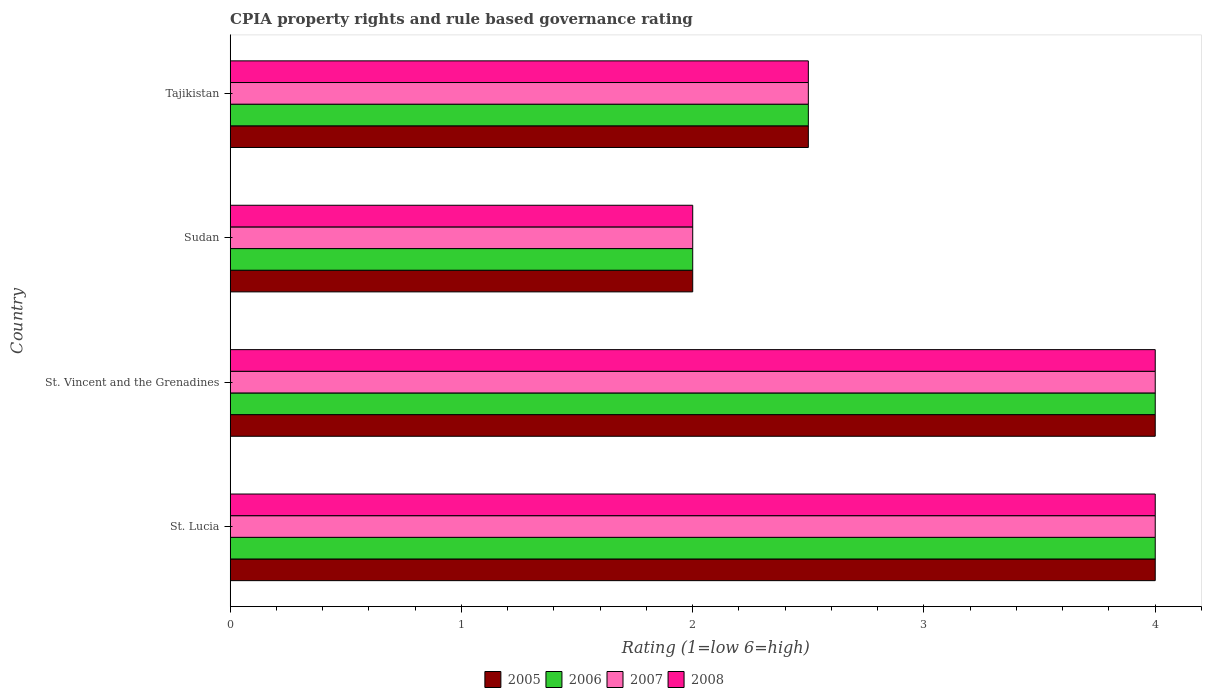How many different coloured bars are there?
Offer a terse response. 4. Are the number of bars on each tick of the Y-axis equal?
Keep it short and to the point. Yes. How many bars are there on the 3rd tick from the top?
Provide a short and direct response. 4. What is the label of the 2nd group of bars from the top?
Offer a terse response. Sudan. What is the CPIA rating in 2005 in Sudan?
Keep it short and to the point. 2. Across all countries, what is the maximum CPIA rating in 2005?
Offer a terse response. 4. In which country was the CPIA rating in 2005 maximum?
Provide a succinct answer. St. Lucia. In which country was the CPIA rating in 2007 minimum?
Give a very brief answer. Sudan. What is the difference between the CPIA rating in 2005 in St. Vincent and the Grenadines and the CPIA rating in 2007 in Tajikistan?
Ensure brevity in your answer.  1.5. What is the average CPIA rating in 2008 per country?
Provide a short and direct response. 3.12. What is the difference between the CPIA rating in 2006 and CPIA rating in 2005 in St. Lucia?
Keep it short and to the point. 0. In how many countries, is the CPIA rating in 2006 greater than 1.8 ?
Keep it short and to the point. 4. What is the ratio of the CPIA rating in 2005 in St. Lucia to that in St. Vincent and the Grenadines?
Ensure brevity in your answer.  1. What is the difference between the highest and the second highest CPIA rating in 2007?
Offer a terse response. 0. In how many countries, is the CPIA rating in 2005 greater than the average CPIA rating in 2005 taken over all countries?
Your response must be concise. 2. Is the sum of the CPIA rating in 2008 in St. Lucia and Tajikistan greater than the maximum CPIA rating in 2005 across all countries?
Give a very brief answer. Yes. Is it the case that in every country, the sum of the CPIA rating in 2006 and CPIA rating in 2007 is greater than the sum of CPIA rating in 2008 and CPIA rating in 2005?
Your answer should be compact. No. What does the 1st bar from the top in Tajikistan represents?
Ensure brevity in your answer.  2008. What does the 4th bar from the bottom in St. Vincent and the Grenadines represents?
Make the answer very short. 2008. Is it the case that in every country, the sum of the CPIA rating in 2006 and CPIA rating in 2007 is greater than the CPIA rating in 2005?
Your answer should be compact. Yes. How many bars are there?
Give a very brief answer. 16. Are all the bars in the graph horizontal?
Offer a terse response. Yes. What is the difference between two consecutive major ticks on the X-axis?
Offer a very short reply. 1. Does the graph contain grids?
Keep it short and to the point. No. Where does the legend appear in the graph?
Offer a very short reply. Bottom center. How many legend labels are there?
Provide a short and direct response. 4. How are the legend labels stacked?
Offer a terse response. Horizontal. What is the title of the graph?
Make the answer very short. CPIA property rights and rule based governance rating. What is the label or title of the Y-axis?
Make the answer very short. Country. What is the Rating (1=low 6=high) in 2005 in St. Lucia?
Offer a terse response. 4. What is the Rating (1=low 6=high) of 2006 in St. Lucia?
Your response must be concise. 4. What is the Rating (1=low 6=high) of 2008 in Tajikistan?
Your response must be concise. 2.5. Across all countries, what is the maximum Rating (1=low 6=high) in 2005?
Your answer should be very brief. 4. Across all countries, what is the maximum Rating (1=low 6=high) in 2006?
Provide a short and direct response. 4. Across all countries, what is the maximum Rating (1=low 6=high) of 2007?
Offer a terse response. 4. Across all countries, what is the maximum Rating (1=low 6=high) in 2008?
Your answer should be compact. 4. Across all countries, what is the minimum Rating (1=low 6=high) of 2007?
Provide a short and direct response. 2. Across all countries, what is the minimum Rating (1=low 6=high) in 2008?
Offer a terse response. 2. What is the total Rating (1=low 6=high) of 2005 in the graph?
Provide a succinct answer. 12.5. What is the total Rating (1=low 6=high) in 2006 in the graph?
Provide a succinct answer. 12.5. What is the difference between the Rating (1=low 6=high) in 2005 in St. Lucia and that in St. Vincent and the Grenadines?
Make the answer very short. 0. What is the difference between the Rating (1=low 6=high) in 2008 in St. Lucia and that in St. Vincent and the Grenadines?
Your answer should be very brief. 0. What is the difference between the Rating (1=low 6=high) of 2006 in St. Lucia and that in Sudan?
Give a very brief answer. 2. What is the difference between the Rating (1=low 6=high) in 2005 in St. Lucia and that in Tajikistan?
Provide a short and direct response. 1.5. What is the difference between the Rating (1=low 6=high) of 2007 in St. Lucia and that in Tajikistan?
Provide a short and direct response. 1.5. What is the difference between the Rating (1=low 6=high) of 2008 in St. Vincent and the Grenadines and that in Sudan?
Your answer should be compact. 2. What is the difference between the Rating (1=low 6=high) in 2005 in St. Vincent and the Grenadines and that in Tajikistan?
Provide a succinct answer. 1.5. What is the difference between the Rating (1=low 6=high) of 2007 in St. Vincent and the Grenadines and that in Tajikistan?
Make the answer very short. 1.5. What is the difference between the Rating (1=low 6=high) of 2008 in St. Vincent and the Grenadines and that in Tajikistan?
Make the answer very short. 1.5. What is the difference between the Rating (1=low 6=high) of 2006 in Sudan and that in Tajikistan?
Provide a succinct answer. -0.5. What is the difference between the Rating (1=low 6=high) in 2005 in St. Lucia and the Rating (1=low 6=high) in 2006 in St. Vincent and the Grenadines?
Provide a succinct answer. 0. What is the difference between the Rating (1=low 6=high) in 2005 in St. Lucia and the Rating (1=low 6=high) in 2007 in St. Vincent and the Grenadines?
Offer a terse response. 0. What is the difference between the Rating (1=low 6=high) of 2005 in St. Lucia and the Rating (1=low 6=high) of 2008 in St. Vincent and the Grenadines?
Provide a short and direct response. 0. What is the difference between the Rating (1=low 6=high) of 2006 in St. Lucia and the Rating (1=low 6=high) of 2008 in St. Vincent and the Grenadines?
Offer a terse response. 0. What is the difference between the Rating (1=low 6=high) in 2007 in St. Lucia and the Rating (1=low 6=high) in 2008 in St. Vincent and the Grenadines?
Offer a terse response. 0. What is the difference between the Rating (1=low 6=high) in 2005 in St. Lucia and the Rating (1=low 6=high) in 2006 in Sudan?
Provide a short and direct response. 2. What is the difference between the Rating (1=low 6=high) in 2005 in St. Lucia and the Rating (1=low 6=high) in 2007 in Sudan?
Make the answer very short. 2. What is the difference between the Rating (1=low 6=high) in 2005 in St. Lucia and the Rating (1=low 6=high) in 2008 in Sudan?
Your response must be concise. 2. What is the difference between the Rating (1=low 6=high) in 2006 in St. Lucia and the Rating (1=low 6=high) in 2008 in Sudan?
Offer a terse response. 2. What is the difference between the Rating (1=low 6=high) of 2007 in St. Lucia and the Rating (1=low 6=high) of 2008 in Sudan?
Offer a terse response. 2. What is the difference between the Rating (1=low 6=high) of 2005 in St. Lucia and the Rating (1=low 6=high) of 2007 in Tajikistan?
Make the answer very short. 1.5. What is the difference between the Rating (1=low 6=high) in 2006 in St. Lucia and the Rating (1=low 6=high) in 2007 in Tajikistan?
Your answer should be very brief. 1.5. What is the difference between the Rating (1=low 6=high) in 2006 in St. Lucia and the Rating (1=low 6=high) in 2008 in Tajikistan?
Provide a succinct answer. 1.5. What is the difference between the Rating (1=low 6=high) of 2007 in St. Lucia and the Rating (1=low 6=high) of 2008 in Tajikistan?
Keep it short and to the point. 1.5. What is the difference between the Rating (1=low 6=high) in 2005 in St. Vincent and the Grenadines and the Rating (1=low 6=high) in 2006 in Sudan?
Provide a succinct answer. 2. What is the difference between the Rating (1=low 6=high) of 2005 in St. Vincent and the Grenadines and the Rating (1=low 6=high) of 2007 in Sudan?
Keep it short and to the point. 2. What is the difference between the Rating (1=low 6=high) of 2006 in St. Vincent and the Grenadines and the Rating (1=low 6=high) of 2007 in Sudan?
Provide a short and direct response. 2. What is the difference between the Rating (1=low 6=high) of 2005 in St. Vincent and the Grenadines and the Rating (1=low 6=high) of 2008 in Tajikistan?
Make the answer very short. 1.5. What is the difference between the Rating (1=low 6=high) of 2006 in St. Vincent and the Grenadines and the Rating (1=low 6=high) of 2008 in Tajikistan?
Your answer should be compact. 1.5. What is the difference between the Rating (1=low 6=high) in 2007 in St. Vincent and the Grenadines and the Rating (1=low 6=high) in 2008 in Tajikistan?
Offer a very short reply. 1.5. What is the difference between the Rating (1=low 6=high) of 2005 in Sudan and the Rating (1=low 6=high) of 2008 in Tajikistan?
Ensure brevity in your answer.  -0.5. What is the difference between the Rating (1=low 6=high) of 2006 in Sudan and the Rating (1=low 6=high) of 2007 in Tajikistan?
Make the answer very short. -0.5. What is the difference between the Rating (1=low 6=high) in 2006 in Sudan and the Rating (1=low 6=high) in 2008 in Tajikistan?
Your answer should be very brief. -0.5. What is the average Rating (1=low 6=high) in 2005 per country?
Offer a terse response. 3.12. What is the average Rating (1=low 6=high) in 2006 per country?
Your response must be concise. 3.12. What is the average Rating (1=low 6=high) of 2007 per country?
Provide a short and direct response. 3.12. What is the average Rating (1=low 6=high) in 2008 per country?
Your answer should be very brief. 3.12. What is the difference between the Rating (1=low 6=high) in 2005 and Rating (1=low 6=high) in 2007 in St. Lucia?
Provide a short and direct response. 0. What is the difference between the Rating (1=low 6=high) of 2007 and Rating (1=low 6=high) of 2008 in St. Lucia?
Make the answer very short. 0. What is the difference between the Rating (1=low 6=high) of 2005 and Rating (1=low 6=high) of 2006 in St. Vincent and the Grenadines?
Keep it short and to the point. 0. What is the difference between the Rating (1=low 6=high) in 2005 and Rating (1=low 6=high) in 2007 in St. Vincent and the Grenadines?
Give a very brief answer. 0. What is the difference between the Rating (1=low 6=high) of 2005 and Rating (1=low 6=high) of 2008 in St. Vincent and the Grenadines?
Provide a short and direct response. 0. What is the difference between the Rating (1=low 6=high) of 2006 and Rating (1=low 6=high) of 2007 in St. Vincent and the Grenadines?
Keep it short and to the point. 0. What is the difference between the Rating (1=low 6=high) of 2007 and Rating (1=low 6=high) of 2008 in St. Vincent and the Grenadines?
Keep it short and to the point. 0. What is the difference between the Rating (1=low 6=high) in 2005 and Rating (1=low 6=high) in 2006 in Sudan?
Offer a terse response. 0. What is the difference between the Rating (1=low 6=high) of 2005 and Rating (1=low 6=high) of 2008 in Sudan?
Offer a terse response. 0. What is the difference between the Rating (1=low 6=high) of 2006 and Rating (1=low 6=high) of 2007 in Sudan?
Make the answer very short. 0. What is the difference between the Rating (1=low 6=high) of 2005 and Rating (1=low 6=high) of 2007 in Tajikistan?
Your answer should be very brief. 0. What is the difference between the Rating (1=low 6=high) in 2006 and Rating (1=low 6=high) in 2008 in Tajikistan?
Ensure brevity in your answer.  0. What is the difference between the Rating (1=low 6=high) in 2007 and Rating (1=low 6=high) in 2008 in Tajikistan?
Offer a terse response. 0. What is the ratio of the Rating (1=low 6=high) of 2005 in St. Lucia to that in St. Vincent and the Grenadines?
Ensure brevity in your answer.  1. What is the ratio of the Rating (1=low 6=high) of 2006 in St. Lucia to that in St. Vincent and the Grenadines?
Give a very brief answer. 1. What is the ratio of the Rating (1=low 6=high) in 2007 in St. Lucia to that in St. Vincent and the Grenadines?
Your answer should be very brief. 1. What is the ratio of the Rating (1=low 6=high) of 2007 in St. Lucia to that in Sudan?
Make the answer very short. 2. What is the ratio of the Rating (1=low 6=high) of 2008 in St. Lucia to that in Sudan?
Provide a short and direct response. 2. What is the ratio of the Rating (1=low 6=high) of 2005 in St. Lucia to that in Tajikistan?
Offer a very short reply. 1.6. What is the ratio of the Rating (1=low 6=high) in 2008 in St. Lucia to that in Tajikistan?
Ensure brevity in your answer.  1.6. What is the ratio of the Rating (1=low 6=high) in 2008 in St. Vincent and the Grenadines to that in Sudan?
Give a very brief answer. 2. What is the ratio of the Rating (1=low 6=high) of 2005 in Sudan to that in Tajikistan?
Provide a succinct answer. 0.8. What is the ratio of the Rating (1=low 6=high) of 2006 in Sudan to that in Tajikistan?
Ensure brevity in your answer.  0.8. What is the ratio of the Rating (1=low 6=high) in 2008 in Sudan to that in Tajikistan?
Make the answer very short. 0.8. What is the difference between the highest and the second highest Rating (1=low 6=high) of 2008?
Provide a short and direct response. 0. What is the difference between the highest and the lowest Rating (1=low 6=high) of 2006?
Offer a terse response. 2. What is the difference between the highest and the lowest Rating (1=low 6=high) of 2007?
Provide a succinct answer. 2. What is the difference between the highest and the lowest Rating (1=low 6=high) in 2008?
Make the answer very short. 2. 